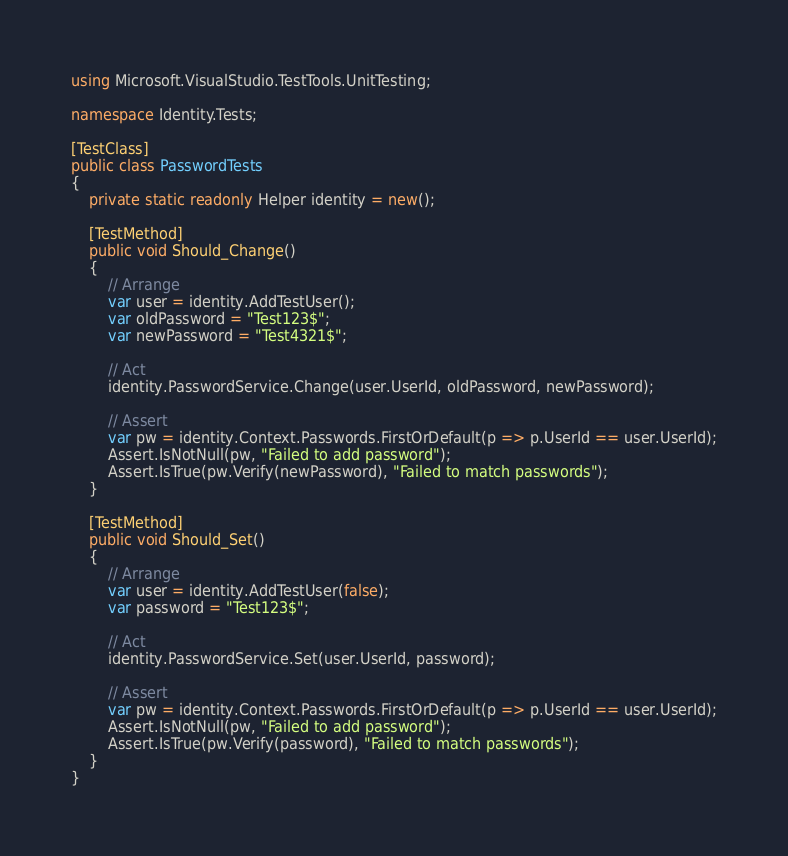Convert code to text. <code><loc_0><loc_0><loc_500><loc_500><_C#_>
using Microsoft.VisualStudio.TestTools.UnitTesting;

namespace Identity.Tests;

[TestClass]
public class PasswordTests
{
    private static readonly Helper identity = new();

    [TestMethod]
    public void Should_Change()
    {
        // Arrange
        var user = identity.AddTestUser();
        var oldPassword = "Test123$";
        var newPassword = "Test4321$";

        // Act
        identity.PasswordService.Change(user.UserId, oldPassword, newPassword);

        // Assert
        var pw = identity.Context.Passwords.FirstOrDefault(p => p.UserId == user.UserId);
        Assert.IsNotNull(pw, "Failed to add password");
        Assert.IsTrue(pw.Verify(newPassword), "Failed to match passwords");
    }

    [TestMethod]
    public void Should_Set()
    {
        // Arrange
        var user = identity.AddTestUser(false);
        var password = "Test123$";

        // Act
        identity.PasswordService.Set(user.UserId, password);

        // Assert
        var pw = identity.Context.Passwords.FirstOrDefault(p => p.UserId == user.UserId);
        Assert.IsNotNull(pw, "Failed to add password");
        Assert.IsTrue(pw.Verify(password), "Failed to match passwords");
    }
}</code> 